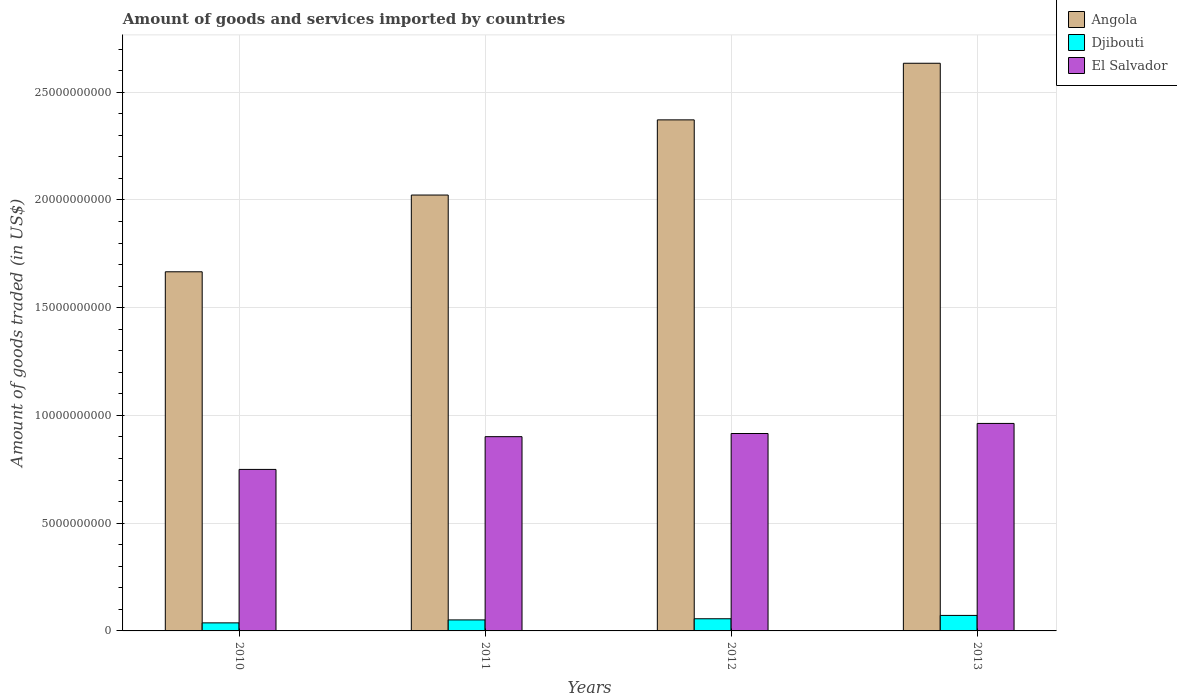How many different coloured bars are there?
Offer a very short reply. 3. Are the number of bars per tick equal to the number of legend labels?
Make the answer very short. Yes. Are the number of bars on each tick of the X-axis equal?
Your answer should be very brief. Yes. How many bars are there on the 4th tick from the left?
Keep it short and to the point. 3. What is the label of the 3rd group of bars from the left?
Your answer should be very brief. 2012. What is the total amount of goods and services imported in Djibouti in 2010?
Provide a succinct answer. 3.74e+08. Across all years, what is the maximum total amount of goods and services imported in Djibouti?
Keep it short and to the point. 7.19e+08. Across all years, what is the minimum total amount of goods and services imported in Angola?
Keep it short and to the point. 1.67e+1. In which year was the total amount of goods and services imported in El Salvador maximum?
Your answer should be very brief. 2013. In which year was the total amount of goods and services imported in El Salvador minimum?
Ensure brevity in your answer.  2010. What is the total total amount of goods and services imported in Djibouti in the graph?
Provide a short and direct response. 2.17e+09. What is the difference between the total amount of goods and services imported in El Salvador in 2011 and that in 2012?
Your answer should be compact. -1.47e+08. What is the difference between the total amount of goods and services imported in Djibouti in 2010 and the total amount of goods and services imported in El Salvador in 2013?
Provide a succinct answer. -9.26e+09. What is the average total amount of goods and services imported in El Salvador per year?
Your answer should be very brief. 8.83e+09. In the year 2010, what is the difference between the total amount of goods and services imported in Angola and total amount of goods and services imported in El Salvador?
Your response must be concise. 9.17e+09. What is the ratio of the total amount of goods and services imported in Angola in 2010 to that in 2011?
Offer a terse response. 0.82. Is the total amount of goods and services imported in Djibouti in 2010 less than that in 2012?
Your response must be concise. Yes. What is the difference between the highest and the second highest total amount of goods and services imported in Djibouti?
Ensure brevity in your answer.  1.55e+08. What is the difference between the highest and the lowest total amount of goods and services imported in El Salvador?
Provide a short and direct response. 2.13e+09. In how many years, is the total amount of goods and services imported in Djibouti greater than the average total amount of goods and services imported in Djibouti taken over all years?
Your response must be concise. 2. Is the sum of the total amount of goods and services imported in Angola in 2010 and 2012 greater than the maximum total amount of goods and services imported in El Salvador across all years?
Ensure brevity in your answer.  Yes. What does the 1st bar from the left in 2011 represents?
Keep it short and to the point. Angola. What does the 2nd bar from the right in 2012 represents?
Provide a succinct answer. Djibouti. Is it the case that in every year, the sum of the total amount of goods and services imported in Djibouti and total amount of goods and services imported in Angola is greater than the total amount of goods and services imported in El Salvador?
Offer a very short reply. Yes. How many bars are there?
Keep it short and to the point. 12. Are all the bars in the graph horizontal?
Make the answer very short. No. How many years are there in the graph?
Your answer should be very brief. 4. Are the values on the major ticks of Y-axis written in scientific E-notation?
Your answer should be compact. No. Does the graph contain any zero values?
Make the answer very short. No. Does the graph contain grids?
Offer a terse response. Yes. Where does the legend appear in the graph?
Provide a succinct answer. Top right. How many legend labels are there?
Offer a very short reply. 3. What is the title of the graph?
Provide a short and direct response. Amount of goods and services imported by countries. Does "South Sudan" appear as one of the legend labels in the graph?
Keep it short and to the point. No. What is the label or title of the Y-axis?
Offer a terse response. Amount of goods traded (in US$). What is the Amount of goods traded (in US$) in Angola in 2010?
Offer a very short reply. 1.67e+1. What is the Amount of goods traded (in US$) in Djibouti in 2010?
Offer a very short reply. 3.74e+08. What is the Amount of goods traded (in US$) of El Salvador in 2010?
Keep it short and to the point. 7.50e+09. What is the Amount of goods traded (in US$) in Angola in 2011?
Your answer should be very brief. 2.02e+1. What is the Amount of goods traded (in US$) of Djibouti in 2011?
Your response must be concise. 5.11e+08. What is the Amount of goods traded (in US$) in El Salvador in 2011?
Offer a very short reply. 9.01e+09. What is the Amount of goods traded (in US$) in Angola in 2012?
Ensure brevity in your answer.  2.37e+1. What is the Amount of goods traded (in US$) in Djibouti in 2012?
Keep it short and to the point. 5.64e+08. What is the Amount of goods traded (in US$) in El Salvador in 2012?
Ensure brevity in your answer.  9.16e+09. What is the Amount of goods traded (in US$) in Angola in 2013?
Offer a terse response. 2.63e+1. What is the Amount of goods traded (in US$) in Djibouti in 2013?
Your response must be concise. 7.19e+08. What is the Amount of goods traded (in US$) of El Salvador in 2013?
Offer a very short reply. 9.63e+09. Across all years, what is the maximum Amount of goods traded (in US$) in Angola?
Provide a succinct answer. 2.63e+1. Across all years, what is the maximum Amount of goods traded (in US$) of Djibouti?
Your answer should be very brief. 7.19e+08. Across all years, what is the maximum Amount of goods traded (in US$) in El Salvador?
Your answer should be very brief. 9.63e+09. Across all years, what is the minimum Amount of goods traded (in US$) in Angola?
Your answer should be very brief. 1.67e+1. Across all years, what is the minimum Amount of goods traded (in US$) in Djibouti?
Offer a very short reply. 3.74e+08. Across all years, what is the minimum Amount of goods traded (in US$) in El Salvador?
Your response must be concise. 7.50e+09. What is the total Amount of goods traded (in US$) in Angola in the graph?
Offer a terse response. 8.70e+1. What is the total Amount of goods traded (in US$) of Djibouti in the graph?
Ensure brevity in your answer.  2.17e+09. What is the total Amount of goods traded (in US$) of El Salvador in the graph?
Provide a short and direct response. 3.53e+1. What is the difference between the Amount of goods traded (in US$) in Angola in 2010 and that in 2011?
Provide a short and direct response. -3.56e+09. What is the difference between the Amount of goods traded (in US$) in Djibouti in 2010 and that in 2011?
Your answer should be compact. -1.37e+08. What is the difference between the Amount of goods traded (in US$) in El Salvador in 2010 and that in 2011?
Keep it short and to the point. -1.52e+09. What is the difference between the Amount of goods traded (in US$) of Angola in 2010 and that in 2012?
Your answer should be compact. -7.05e+09. What is the difference between the Amount of goods traded (in US$) of Djibouti in 2010 and that in 2012?
Offer a very short reply. -1.91e+08. What is the difference between the Amount of goods traded (in US$) in El Salvador in 2010 and that in 2012?
Offer a terse response. -1.67e+09. What is the difference between the Amount of goods traded (in US$) of Angola in 2010 and that in 2013?
Provide a succinct answer. -9.68e+09. What is the difference between the Amount of goods traded (in US$) in Djibouti in 2010 and that in 2013?
Provide a short and direct response. -3.46e+08. What is the difference between the Amount of goods traded (in US$) in El Salvador in 2010 and that in 2013?
Offer a terse response. -2.13e+09. What is the difference between the Amount of goods traded (in US$) of Angola in 2011 and that in 2012?
Your response must be concise. -3.49e+09. What is the difference between the Amount of goods traded (in US$) in Djibouti in 2011 and that in 2012?
Offer a terse response. -5.39e+07. What is the difference between the Amount of goods traded (in US$) in El Salvador in 2011 and that in 2012?
Keep it short and to the point. -1.47e+08. What is the difference between the Amount of goods traded (in US$) of Angola in 2011 and that in 2013?
Your answer should be compact. -6.12e+09. What is the difference between the Amount of goods traded (in US$) in Djibouti in 2011 and that in 2013?
Provide a short and direct response. -2.09e+08. What is the difference between the Amount of goods traded (in US$) in El Salvador in 2011 and that in 2013?
Make the answer very short. -6.14e+08. What is the difference between the Amount of goods traded (in US$) of Angola in 2012 and that in 2013?
Make the answer very short. -2.63e+09. What is the difference between the Amount of goods traded (in US$) of Djibouti in 2012 and that in 2013?
Your response must be concise. -1.55e+08. What is the difference between the Amount of goods traded (in US$) in El Salvador in 2012 and that in 2013?
Keep it short and to the point. -4.68e+08. What is the difference between the Amount of goods traded (in US$) of Angola in 2010 and the Amount of goods traded (in US$) of Djibouti in 2011?
Provide a short and direct response. 1.62e+1. What is the difference between the Amount of goods traded (in US$) in Angola in 2010 and the Amount of goods traded (in US$) in El Salvador in 2011?
Your answer should be compact. 7.65e+09. What is the difference between the Amount of goods traded (in US$) of Djibouti in 2010 and the Amount of goods traded (in US$) of El Salvador in 2011?
Offer a terse response. -8.64e+09. What is the difference between the Amount of goods traded (in US$) in Angola in 2010 and the Amount of goods traded (in US$) in Djibouti in 2012?
Offer a very short reply. 1.61e+1. What is the difference between the Amount of goods traded (in US$) in Angola in 2010 and the Amount of goods traded (in US$) in El Salvador in 2012?
Make the answer very short. 7.51e+09. What is the difference between the Amount of goods traded (in US$) in Djibouti in 2010 and the Amount of goods traded (in US$) in El Salvador in 2012?
Keep it short and to the point. -8.79e+09. What is the difference between the Amount of goods traded (in US$) of Angola in 2010 and the Amount of goods traded (in US$) of Djibouti in 2013?
Your answer should be compact. 1.59e+1. What is the difference between the Amount of goods traded (in US$) in Angola in 2010 and the Amount of goods traded (in US$) in El Salvador in 2013?
Your answer should be very brief. 7.04e+09. What is the difference between the Amount of goods traded (in US$) in Djibouti in 2010 and the Amount of goods traded (in US$) in El Salvador in 2013?
Provide a short and direct response. -9.26e+09. What is the difference between the Amount of goods traded (in US$) of Angola in 2011 and the Amount of goods traded (in US$) of Djibouti in 2012?
Provide a short and direct response. 1.97e+1. What is the difference between the Amount of goods traded (in US$) of Angola in 2011 and the Amount of goods traded (in US$) of El Salvador in 2012?
Provide a succinct answer. 1.11e+1. What is the difference between the Amount of goods traded (in US$) in Djibouti in 2011 and the Amount of goods traded (in US$) in El Salvador in 2012?
Provide a succinct answer. -8.65e+09. What is the difference between the Amount of goods traded (in US$) of Angola in 2011 and the Amount of goods traded (in US$) of Djibouti in 2013?
Your answer should be very brief. 1.95e+1. What is the difference between the Amount of goods traded (in US$) in Angola in 2011 and the Amount of goods traded (in US$) in El Salvador in 2013?
Your answer should be compact. 1.06e+1. What is the difference between the Amount of goods traded (in US$) in Djibouti in 2011 and the Amount of goods traded (in US$) in El Salvador in 2013?
Your answer should be very brief. -9.12e+09. What is the difference between the Amount of goods traded (in US$) of Angola in 2012 and the Amount of goods traded (in US$) of Djibouti in 2013?
Provide a succinct answer. 2.30e+1. What is the difference between the Amount of goods traded (in US$) in Angola in 2012 and the Amount of goods traded (in US$) in El Salvador in 2013?
Your answer should be very brief. 1.41e+1. What is the difference between the Amount of goods traded (in US$) of Djibouti in 2012 and the Amount of goods traded (in US$) of El Salvador in 2013?
Make the answer very short. -9.06e+09. What is the average Amount of goods traded (in US$) of Angola per year?
Your answer should be very brief. 2.17e+1. What is the average Amount of goods traded (in US$) in Djibouti per year?
Your answer should be very brief. 5.42e+08. What is the average Amount of goods traded (in US$) in El Salvador per year?
Give a very brief answer. 8.83e+09. In the year 2010, what is the difference between the Amount of goods traded (in US$) of Angola and Amount of goods traded (in US$) of Djibouti?
Your answer should be compact. 1.63e+1. In the year 2010, what is the difference between the Amount of goods traded (in US$) of Angola and Amount of goods traded (in US$) of El Salvador?
Offer a terse response. 9.17e+09. In the year 2010, what is the difference between the Amount of goods traded (in US$) of Djibouti and Amount of goods traded (in US$) of El Salvador?
Provide a succinct answer. -7.12e+09. In the year 2011, what is the difference between the Amount of goods traded (in US$) of Angola and Amount of goods traded (in US$) of Djibouti?
Provide a succinct answer. 1.97e+1. In the year 2011, what is the difference between the Amount of goods traded (in US$) in Angola and Amount of goods traded (in US$) in El Salvador?
Give a very brief answer. 1.12e+1. In the year 2011, what is the difference between the Amount of goods traded (in US$) in Djibouti and Amount of goods traded (in US$) in El Salvador?
Make the answer very short. -8.50e+09. In the year 2012, what is the difference between the Amount of goods traded (in US$) of Angola and Amount of goods traded (in US$) of Djibouti?
Provide a short and direct response. 2.32e+1. In the year 2012, what is the difference between the Amount of goods traded (in US$) of Angola and Amount of goods traded (in US$) of El Salvador?
Ensure brevity in your answer.  1.46e+1. In the year 2012, what is the difference between the Amount of goods traded (in US$) in Djibouti and Amount of goods traded (in US$) in El Salvador?
Make the answer very short. -8.60e+09. In the year 2013, what is the difference between the Amount of goods traded (in US$) in Angola and Amount of goods traded (in US$) in Djibouti?
Your response must be concise. 2.56e+1. In the year 2013, what is the difference between the Amount of goods traded (in US$) of Angola and Amount of goods traded (in US$) of El Salvador?
Offer a terse response. 1.67e+1. In the year 2013, what is the difference between the Amount of goods traded (in US$) in Djibouti and Amount of goods traded (in US$) in El Salvador?
Your answer should be compact. -8.91e+09. What is the ratio of the Amount of goods traded (in US$) of Angola in 2010 to that in 2011?
Provide a succinct answer. 0.82. What is the ratio of the Amount of goods traded (in US$) in Djibouti in 2010 to that in 2011?
Ensure brevity in your answer.  0.73. What is the ratio of the Amount of goods traded (in US$) of El Salvador in 2010 to that in 2011?
Offer a very short reply. 0.83. What is the ratio of the Amount of goods traded (in US$) in Angola in 2010 to that in 2012?
Offer a very short reply. 0.7. What is the ratio of the Amount of goods traded (in US$) of Djibouti in 2010 to that in 2012?
Keep it short and to the point. 0.66. What is the ratio of the Amount of goods traded (in US$) of El Salvador in 2010 to that in 2012?
Provide a short and direct response. 0.82. What is the ratio of the Amount of goods traded (in US$) in Angola in 2010 to that in 2013?
Offer a terse response. 0.63. What is the ratio of the Amount of goods traded (in US$) in Djibouti in 2010 to that in 2013?
Make the answer very short. 0.52. What is the ratio of the Amount of goods traded (in US$) in El Salvador in 2010 to that in 2013?
Provide a short and direct response. 0.78. What is the ratio of the Amount of goods traded (in US$) of Angola in 2011 to that in 2012?
Keep it short and to the point. 0.85. What is the ratio of the Amount of goods traded (in US$) of Djibouti in 2011 to that in 2012?
Provide a short and direct response. 0.9. What is the ratio of the Amount of goods traded (in US$) in Angola in 2011 to that in 2013?
Your answer should be compact. 0.77. What is the ratio of the Amount of goods traded (in US$) in Djibouti in 2011 to that in 2013?
Keep it short and to the point. 0.71. What is the ratio of the Amount of goods traded (in US$) of El Salvador in 2011 to that in 2013?
Your answer should be very brief. 0.94. What is the ratio of the Amount of goods traded (in US$) in Angola in 2012 to that in 2013?
Offer a very short reply. 0.9. What is the ratio of the Amount of goods traded (in US$) of Djibouti in 2012 to that in 2013?
Provide a short and direct response. 0.78. What is the ratio of the Amount of goods traded (in US$) of El Salvador in 2012 to that in 2013?
Give a very brief answer. 0.95. What is the difference between the highest and the second highest Amount of goods traded (in US$) of Angola?
Provide a short and direct response. 2.63e+09. What is the difference between the highest and the second highest Amount of goods traded (in US$) in Djibouti?
Make the answer very short. 1.55e+08. What is the difference between the highest and the second highest Amount of goods traded (in US$) of El Salvador?
Offer a terse response. 4.68e+08. What is the difference between the highest and the lowest Amount of goods traded (in US$) of Angola?
Give a very brief answer. 9.68e+09. What is the difference between the highest and the lowest Amount of goods traded (in US$) of Djibouti?
Your answer should be very brief. 3.46e+08. What is the difference between the highest and the lowest Amount of goods traded (in US$) of El Salvador?
Provide a short and direct response. 2.13e+09. 